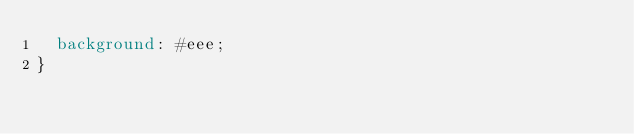<code> <loc_0><loc_0><loc_500><loc_500><_CSS_>  background: #eee;
}
</code> 